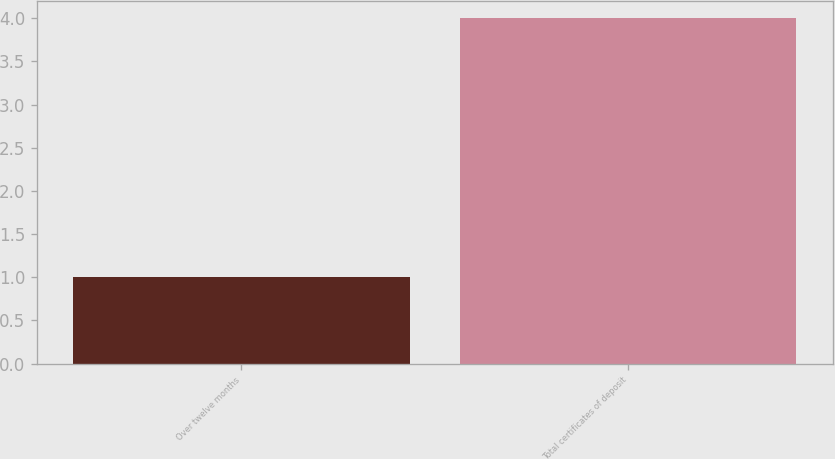Convert chart. <chart><loc_0><loc_0><loc_500><loc_500><bar_chart><fcel>Over twelve months<fcel>Total certificates of deposit<nl><fcel>1<fcel>4<nl></chart> 